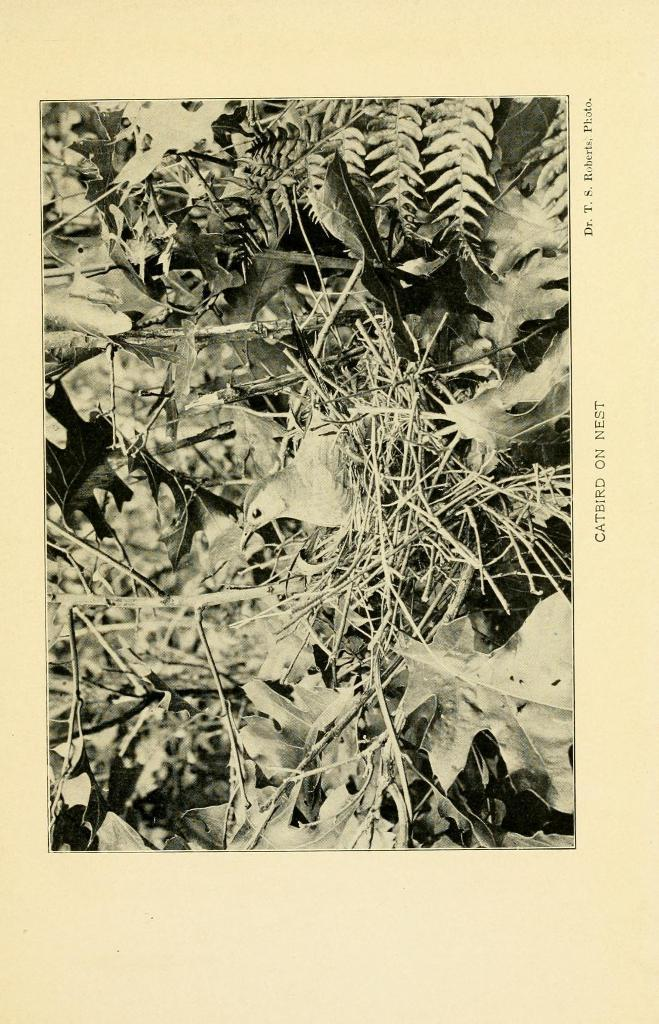What is depicted on the paper in the image? There is a photograph on a paper in the image. What can be seen in the photograph? The photograph contains an image of a bird. Where is the bird located in the image? The bird is in a nest in the image. What is the nest situated on? The nest is on a tree in the image. What type of army can be seen marching through the tree in the image? There is no army present in the image; it features a photograph of a bird in a nest on a tree. What type of toad can be seen sitting on the bird's nest in the image? There is no toad present in the image; it features a photograph of a bird in a nest on a tree. 